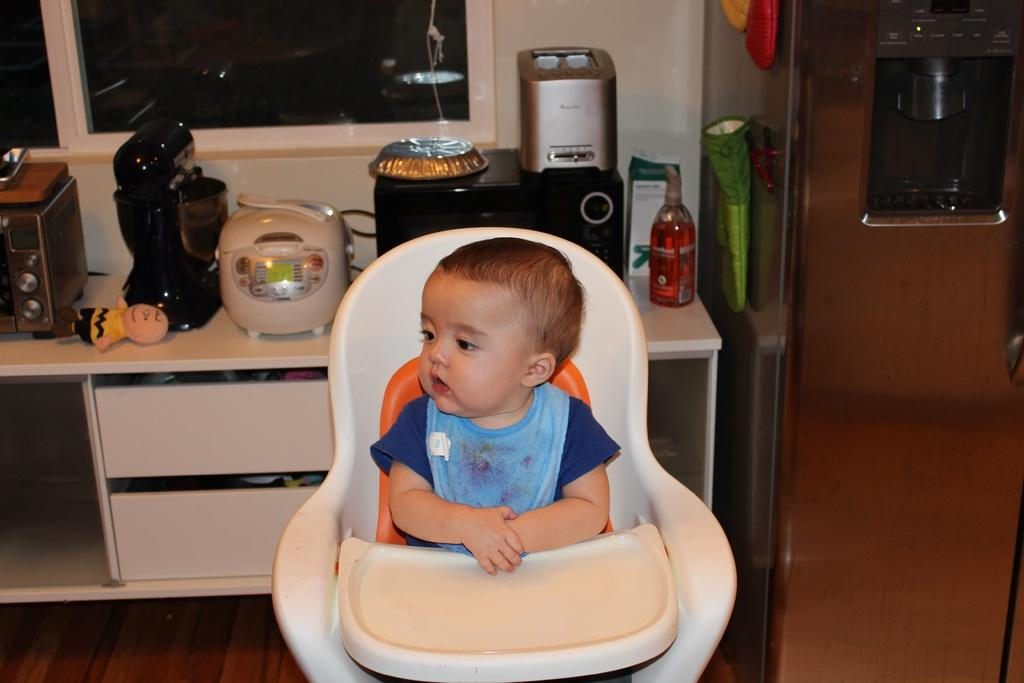What is the main subject of the image? There is a child in the image. What is the child doing in the image? The child is seated in a chair. What can be seen behind the child in the image? There are objects on a table behind the child. What is the profit margin of the copper objects on the table in the image? There is no information about profit margins or copper objects in the image. The image only shows a child seated in a chair with objects on a table behind them. 